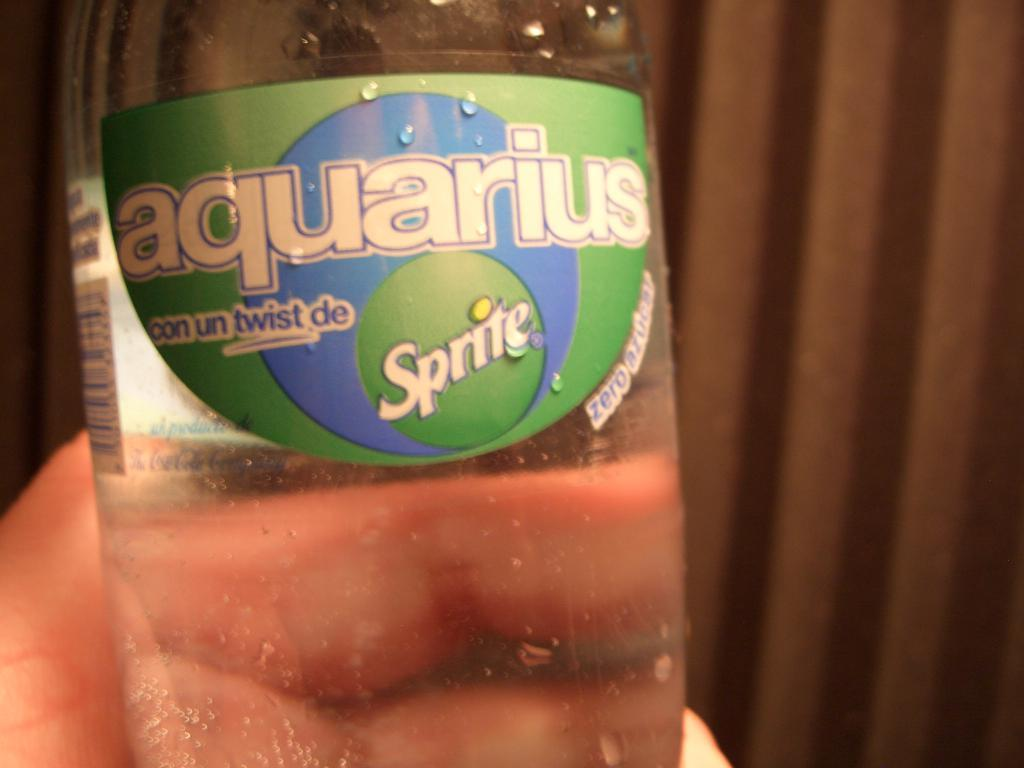What is being held by the hand in the image? There is a hand holding a bottle in the image. What is inside the bottle? The bottle contains text. What type of covering can be seen in the image? There is a curtain visible in the image. How many cherries are on the kitten in the image? There is no kitten or cherries present in the image. 